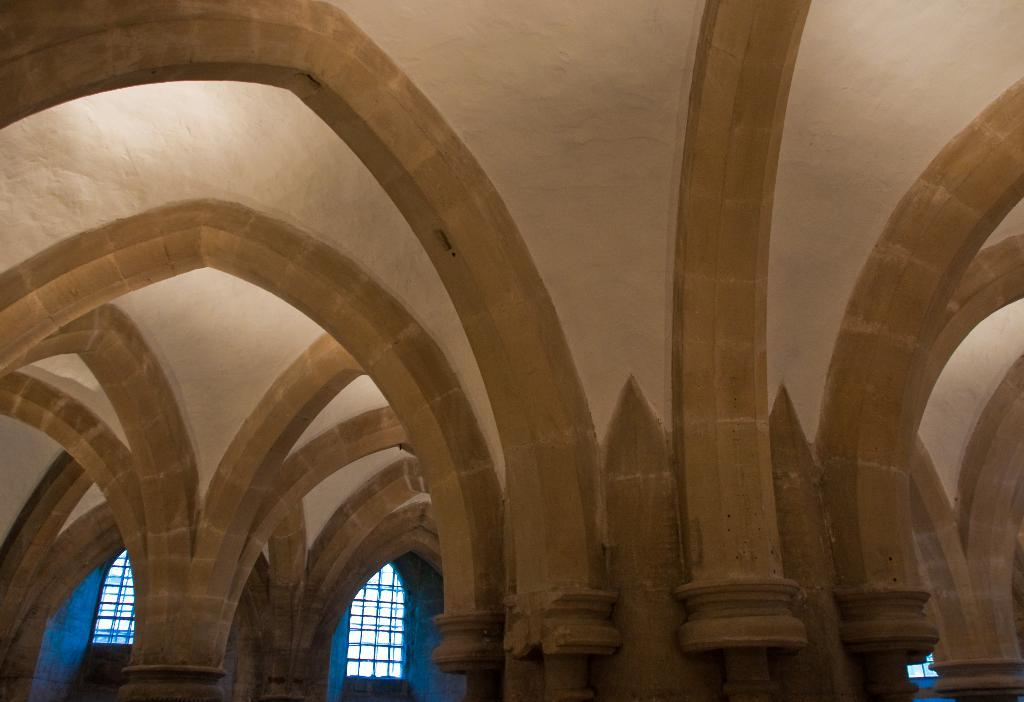What type of structure is present in the image? There is an arch in the image. What other features can be seen at the bottom of the image? There are windows at the bottom of the image. Is there any specific area of the arch that is highlighted? The arch has a light focus on the left side. What type of nerve can be seen in the image? There is no nerve present in the image; it features an arch and windows. What type of locket is hanging from the arch in the image? There is no locket present in the image; it only features an arch and windows. 